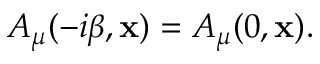Convert formula to latex. <formula><loc_0><loc_0><loc_500><loc_500>A _ { \mu } ( - i \beta , { x } ) = A _ { \mu } ( 0 , { x } ) .</formula> 